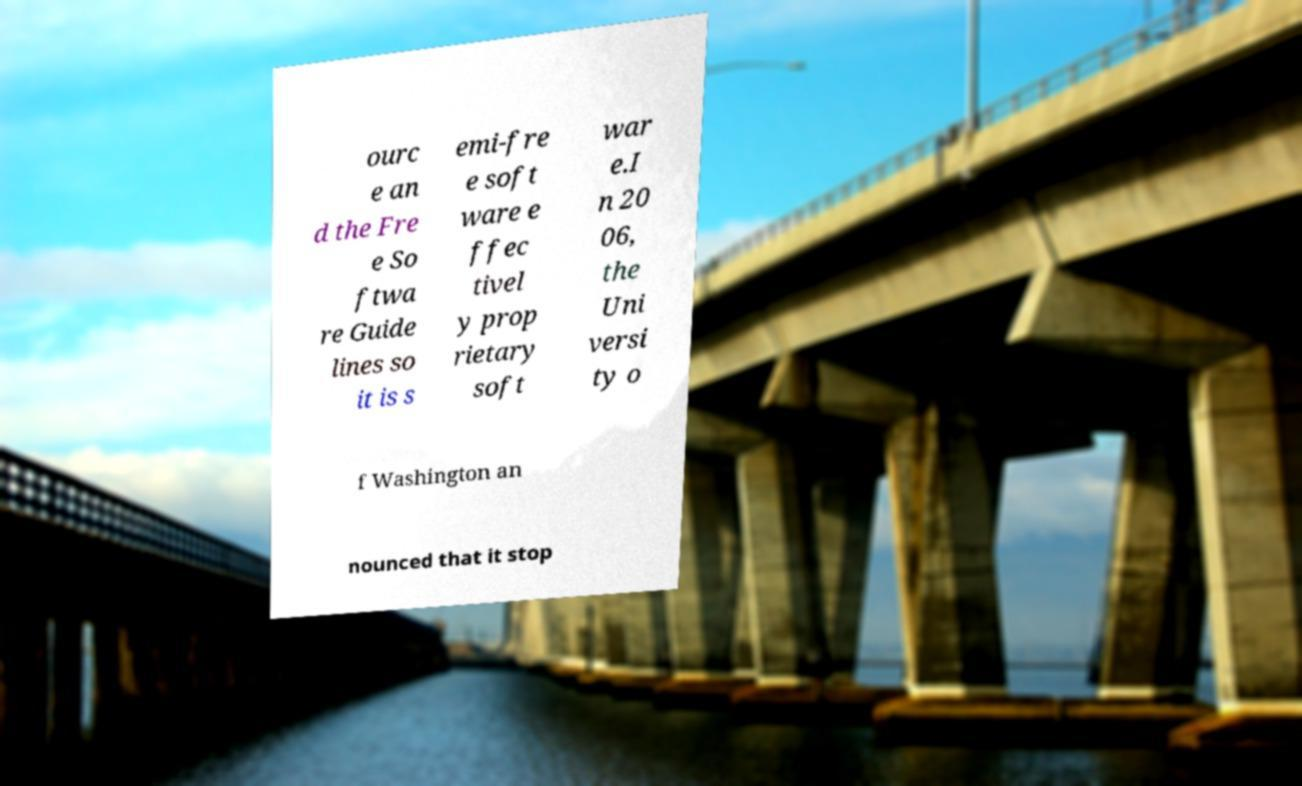Could you extract and type out the text from this image? ourc e an d the Fre e So ftwa re Guide lines so it is s emi-fre e soft ware e ffec tivel y prop rietary soft war e.I n 20 06, the Uni versi ty o f Washington an nounced that it stop 